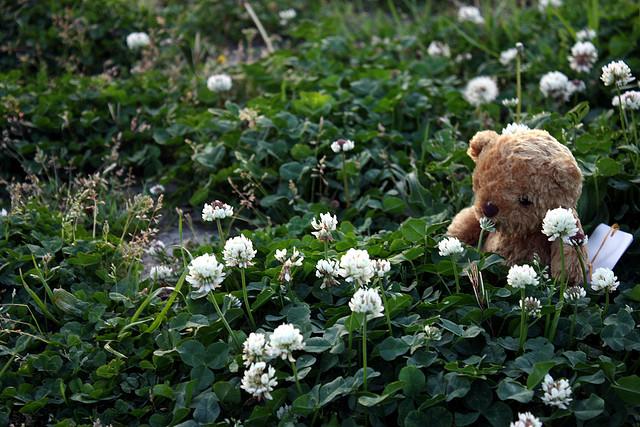Is the bear real?
Keep it brief. No. What color is the bear?
Write a very short answer. Brown. Is this the bear's natural environment?
Short answer required. No. Is she selling teddy bears?
Be succinct. No. 